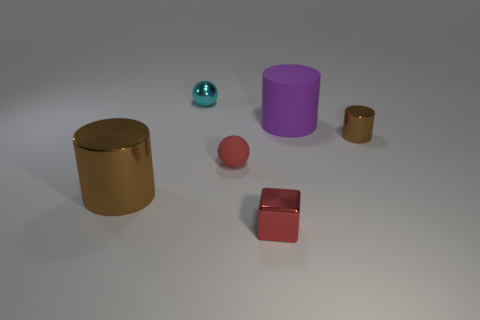Can you describe the colors of the objects in this image? Certainly! The image showcases a collection of objects with varied hues. On the left, there is a large cylinder with a lustrous gold finish. In the center foreground lies a maroon matte cube, while a medium-sized cylinder stands out in a bold purple to the right of the cube. Additionally, there is a small brown cylinder and a tiny teal sphere, adding a nice contrast to the prevailing colors in the scene. 